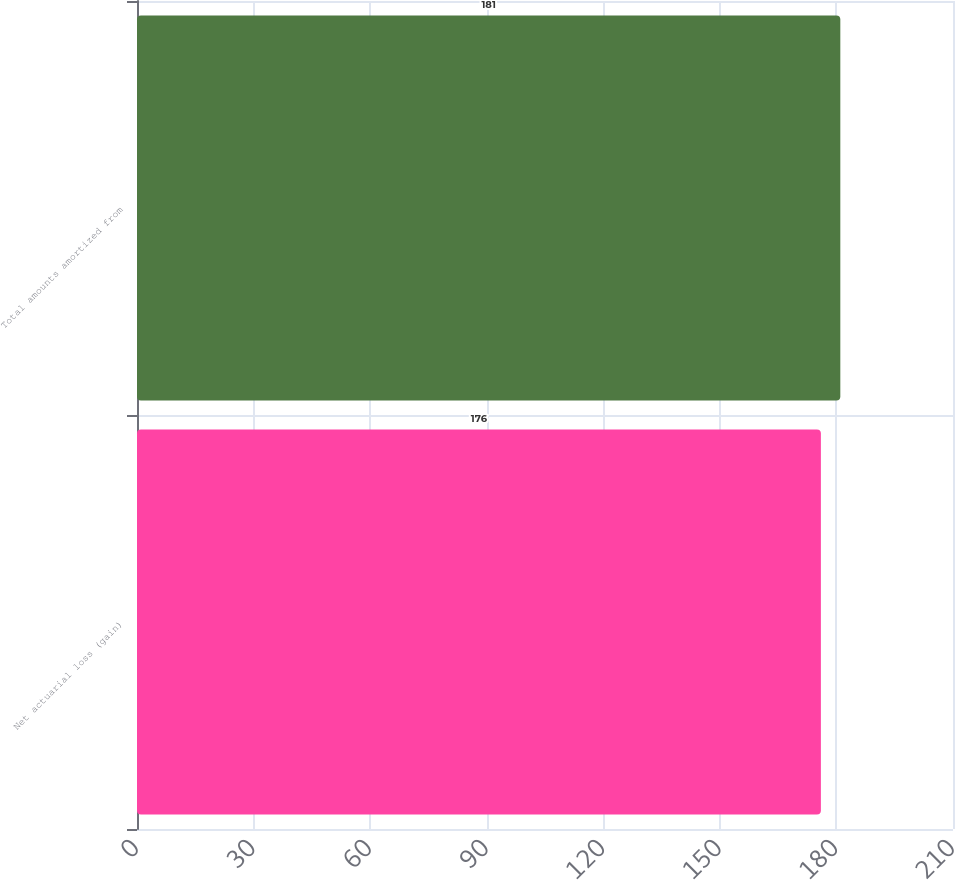Convert chart. <chart><loc_0><loc_0><loc_500><loc_500><bar_chart><fcel>Net actuarial loss (gain)<fcel>Total amounts amortized from<nl><fcel>176<fcel>181<nl></chart> 